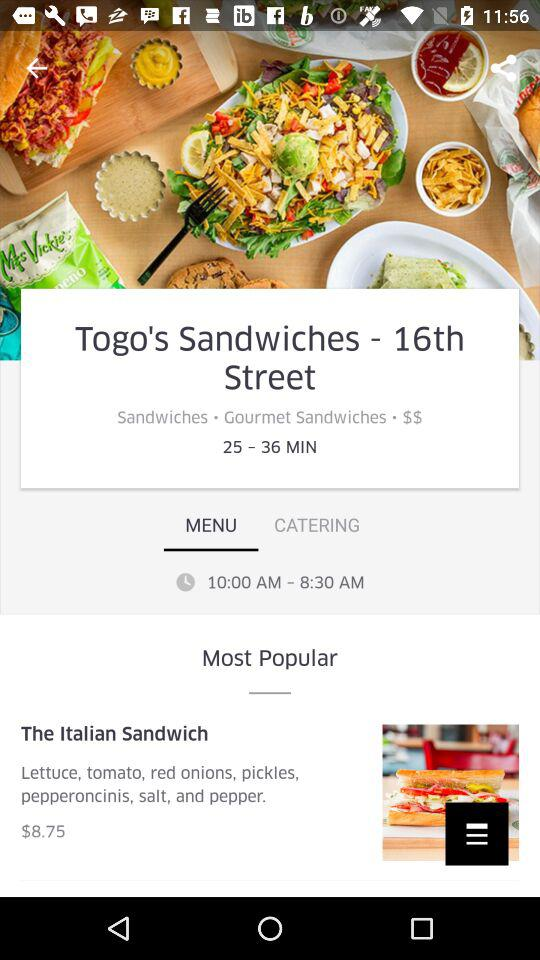What is the price of the Italian sandwich? The price is $8.75. 